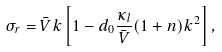<formula> <loc_0><loc_0><loc_500><loc_500>\sigma _ { r } = \bar { V } k \left [ 1 - d _ { 0 } \frac { \kappa _ { l } } { \bar { V } } ( 1 + n ) k ^ { 2 } \right ] ,</formula> 